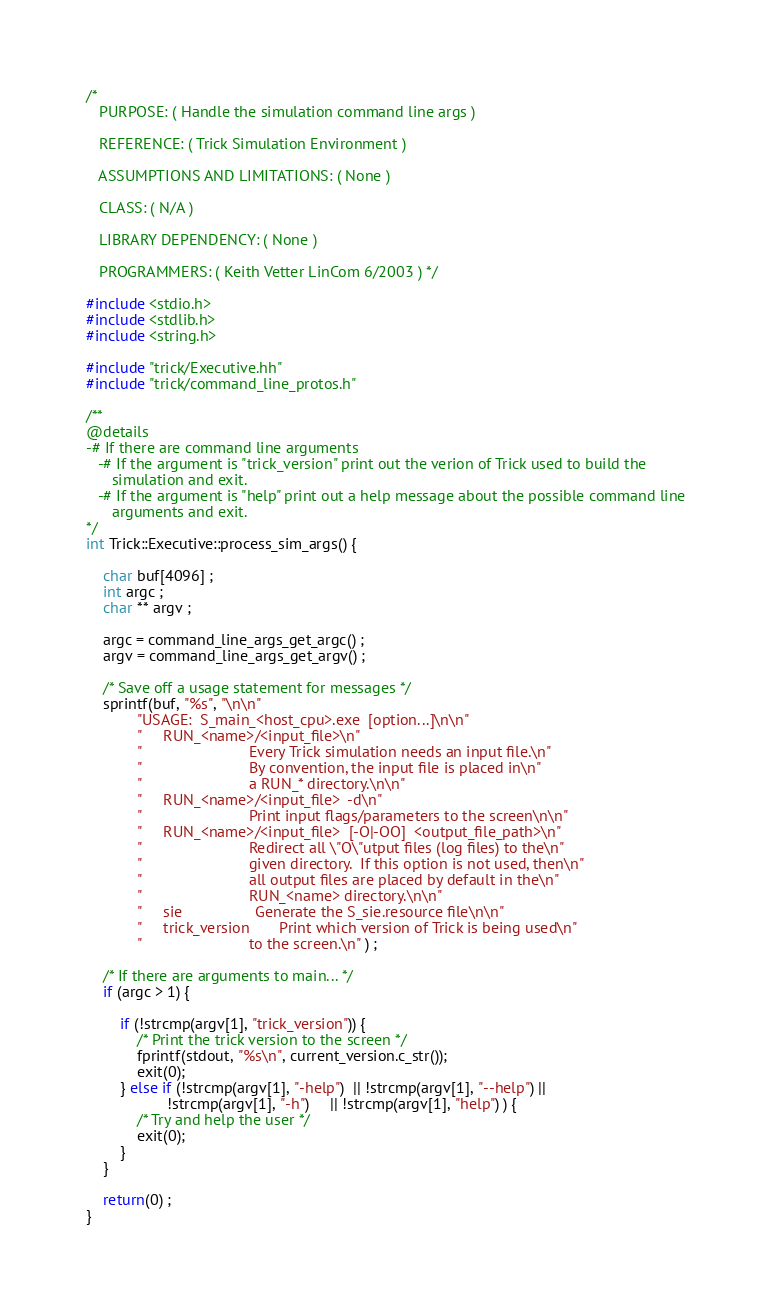<code> <loc_0><loc_0><loc_500><loc_500><_C++_>/*
   PURPOSE: ( Handle the simulation command line args )

   REFERENCE: ( Trick Simulation Environment )

   ASSUMPTIONS AND LIMITATIONS: ( None )

   CLASS: ( N/A )

   LIBRARY DEPENDENCY: ( None )

   PROGRAMMERS: ( Keith Vetter LinCom 6/2003 ) */

#include <stdio.h>
#include <stdlib.h>
#include <string.h>

#include "trick/Executive.hh"
#include "trick/command_line_protos.h"

/**
@details
-# If there are command line arguments
   -# If the argument is "trick_version" print out the verion of Trick used to build the
      simulation and exit.
   -# If the argument is "help" print out a help message about the possible command line
      arguments and exit.
*/
int Trick::Executive::process_sim_args() {

    char buf[4096] ;
    int argc ;
    char ** argv ;

    argc = command_line_args_get_argc() ;
    argv = command_line_args_get_argv() ;

    /* Save off a usage statement for messages */
    sprintf(buf, "%s", "\n\n"
            "USAGE:  S_main_<host_cpu>.exe  [option...]\n\n"
            "     RUN_<name>/<input_file>\n"
            "                         Every Trick simulation needs an input file.\n"
            "                         By convention, the input file is placed in\n"
            "                         a RUN_* directory.\n\n"
            "     RUN_<name>/<input_file>  -d\n"
            "                         Print input flags/parameters to the screen\n\n"
            "     RUN_<name>/<input_file>  [-O|-OO]  <output_file_path>\n"
            "                         Redirect all \"O\"utput files (log files) to the\n"
            "                         given directory.  If this option is not used, then\n"
            "                         all output files are placed by default in the\n"
            "                         RUN_<name> directory.\n\n"
            "     sie                 Generate the S_sie.resource file\n\n"
            "     trick_version       Print which version of Trick is being used\n"
            "                         to the screen.\n" ) ;

    /* If there are arguments to main... */
    if (argc > 1) {

        if (!strcmp(argv[1], "trick_version")) {
            /* Print the trick version to the screen */
            fprintf(stdout, "%s\n", current_version.c_str());
            exit(0);
        } else if (!strcmp(argv[1], "-help")  || !strcmp(argv[1], "--help") ||
                   !strcmp(argv[1], "-h")     || !strcmp(argv[1], "help") ) {
            /* Try and help the user */
            exit(0);
        }
    }

    return(0) ;
}

</code> 